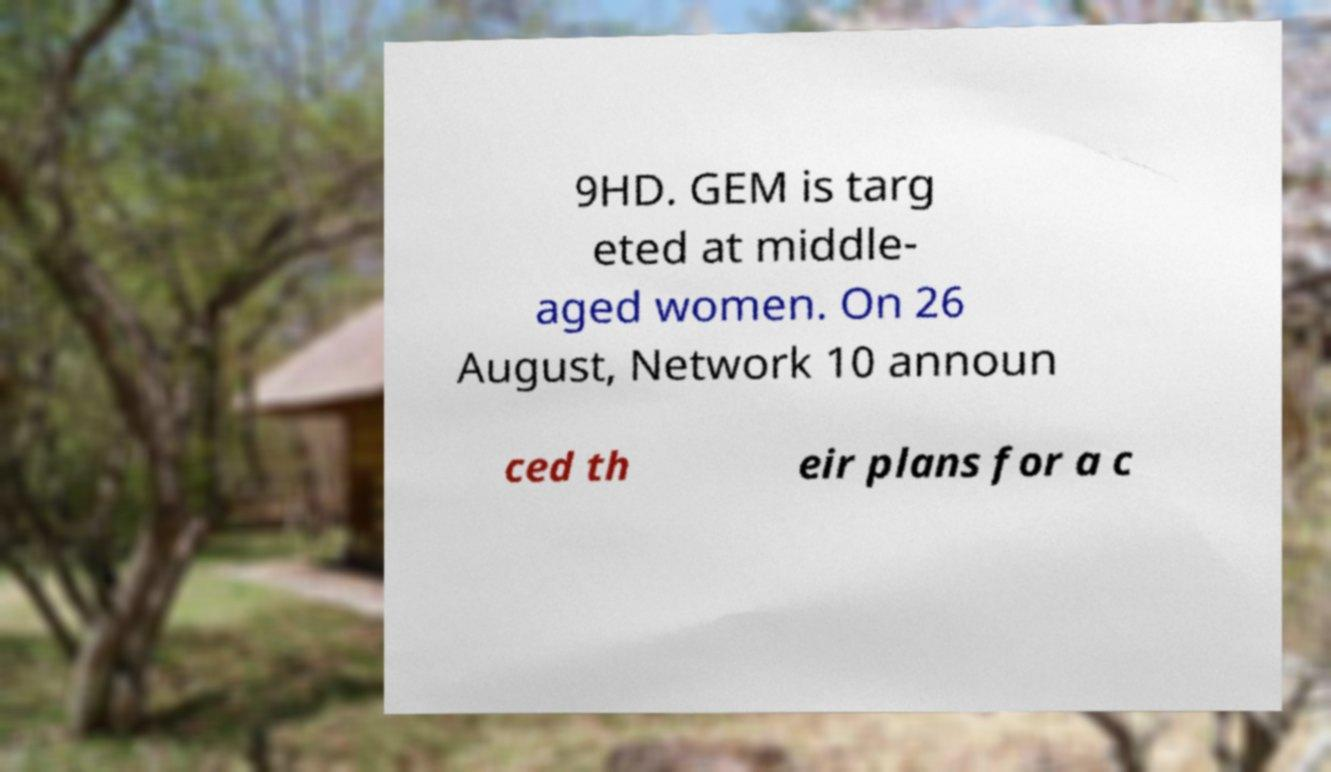Can you accurately transcribe the text from the provided image for me? 9HD. GEM is targ eted at middle- aged women. On 26 August, Network 10 announ ced th eir plans for a c 